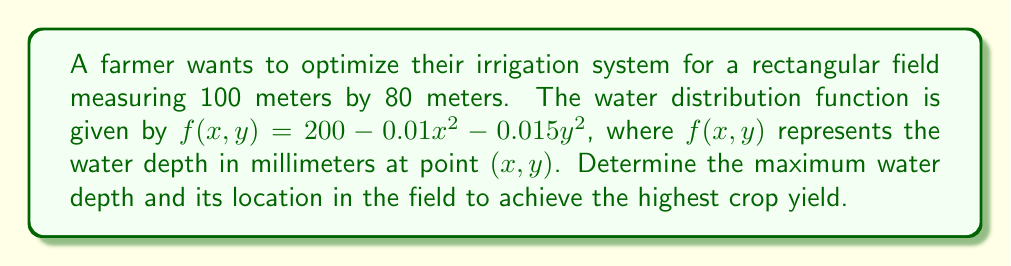Teach me how to tackle this problem. To solve this optimization problem, we'll use multivariable calculus techniques:

1. Identify the function to be optimized:
   $f(x,y) = 200 - 0.01x^2 - 0.015y^2$

2. Find the partial derivatives:
   $\frac{\partial f}{\partial x} = -0.02x$
   $\frac{\partial f}{\partial y} = -0.03y$

3. Set both partial derivatives to zero to find critical points:
   $-0.02x = 0 \implies x = 0$
   $-0.03y = 0 \implies y = 0$

4. The critical point is $(0,0)$, which is within the field boundaries.

5. Evaluate the function at the critical point:
   $f(0,0) = 200 - 0.01(0)^2 - 0.015(0)^2 = 200$ mm

6. Check the field boundaries:
   At $x = 0$, $y = 80$: $f(0,80) = 200 - 0.01(0)^2 - 0.015(80)^2 = 104$ mm
   At $x = 100$, $y = 0$: $f(100,0) = 200 - 0.01(100)^2 - 0.015(0)^2 = 100$ mm
   At $x = 100$, $y = 80$: $f(100,80) = 200 - 0.01(100)^2 - 0.015(80)^2 = 4$ mm

7. Compute the Hessian matrix to confirm it's a maximum:
   $H = \begin{bmatrix} 
   \frac{\partial^2 f}{\partial x^2} & \frac{\partial^2 f}{\partial x \partial y} \\
   \frac{\partial^2 f}{\partial y \partial x} & \frac{\partial^2 f}{\partial y^2}
   \end{bmatrix} = \begin{bmatrix}
   -0.02 & 0 \\
   0 & -0.03
   \end{bmatrix}$

   Both eigenvalues are negative, confirming a local maximum.

Therefore, the maximum water depth is 200 mm, located at the center of the field (0,0).
Answer: 200 mm at (0,0) 